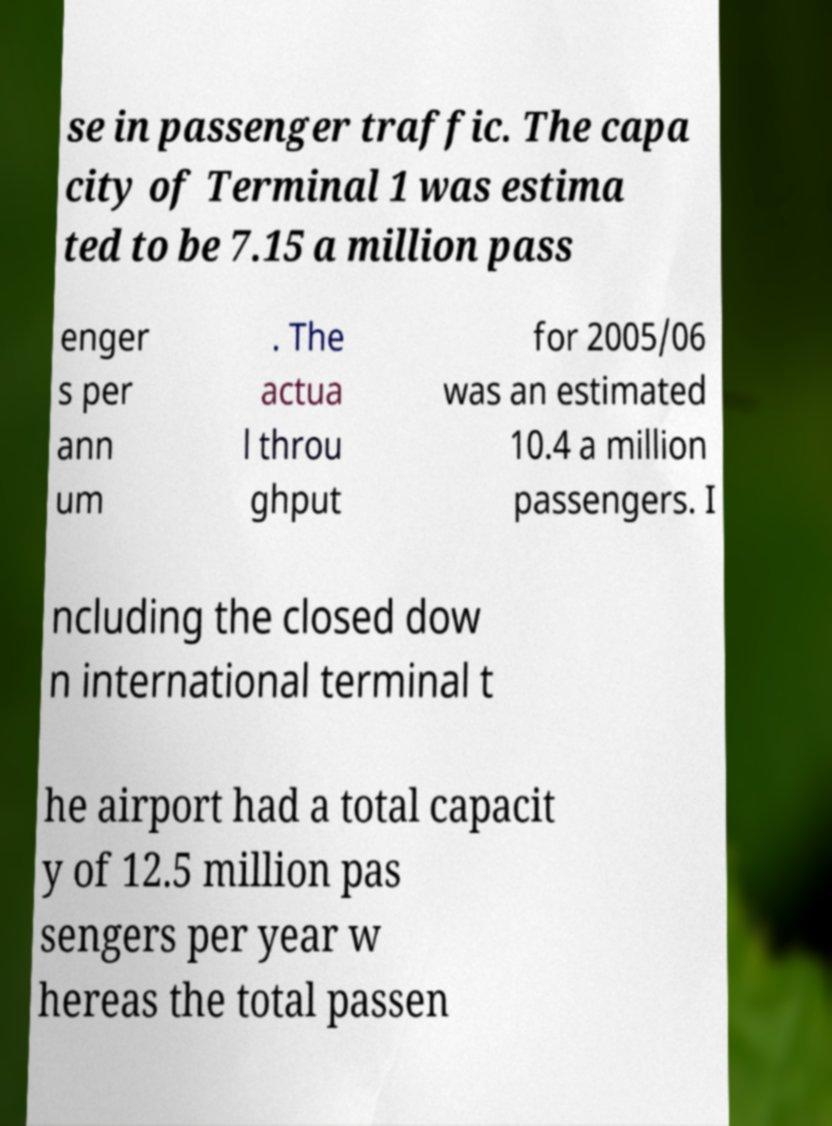Can you read and provide the text displayed in the image?This photo seems to have some interesting text. Can you extract and type it out for me? se in passenger traffic. The capa city of Terminal 1 was estima ted to be 7.15 a million pass enger s per ann um . The actua l throu ghput for 2005/06 was an estimated 10.4 a million passengers. I ncluding the closed dow n international terminal t he airport had a total capacit y of 12.5 million pas sengers per year w hereas the total passen 